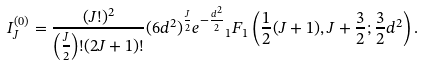Convert formula to latex. <formula><loc_0><loc_0><loc_500><loc_500>I _ { J } ^ { ( 0 ) } = \frac { ( J ! ) ^ { 2 } } { \left ( \frac { J } { 2 } \right ) ! ( 2 J + 1 ) ! } ( 6 d ^ { 2 } ) ^ { \frac { J } { 2 } } e ^ { - \frac { d ^ { 2 } } { 2 } } { _ { 1 } F _ { 1 } } \left ( \frac { 1 } { 2 } ( J + 1 ) , J + \frac { 3 } { 2 } ; \frac { 3 } { 2 } d ^ { 2 } \right ) .</formula> 